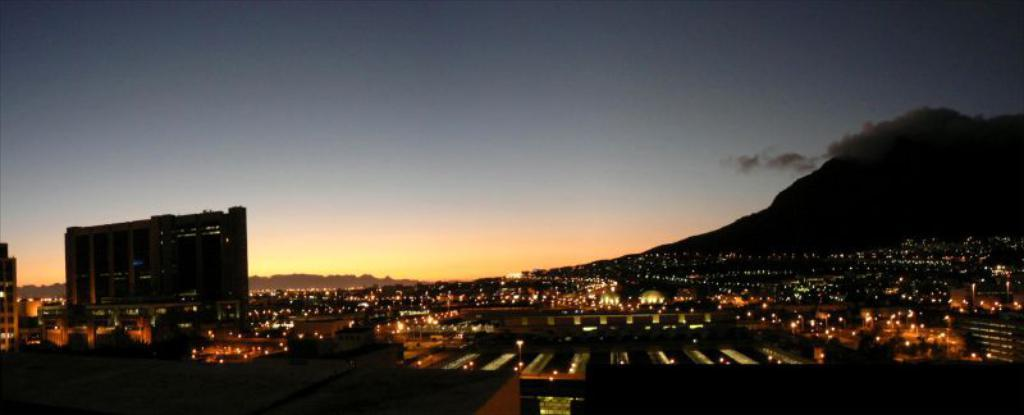What type of structures can be seen in the image? There are houses, buildings, and street lights visible in the image. What natural elements are present in the image? There are trees and a mountain visible in the image. What is the condition of the sky in the background? The sky is visible in the background, and the image is taken during night. What is the source of illumination in the image? Lights are present in the image, including street lights and lights from the buildings. What type of stamp can be seen on the mountain in the image? There is no stamp present on the mountain in the image. How does the pump function in the image? There is no pump present in the image. 